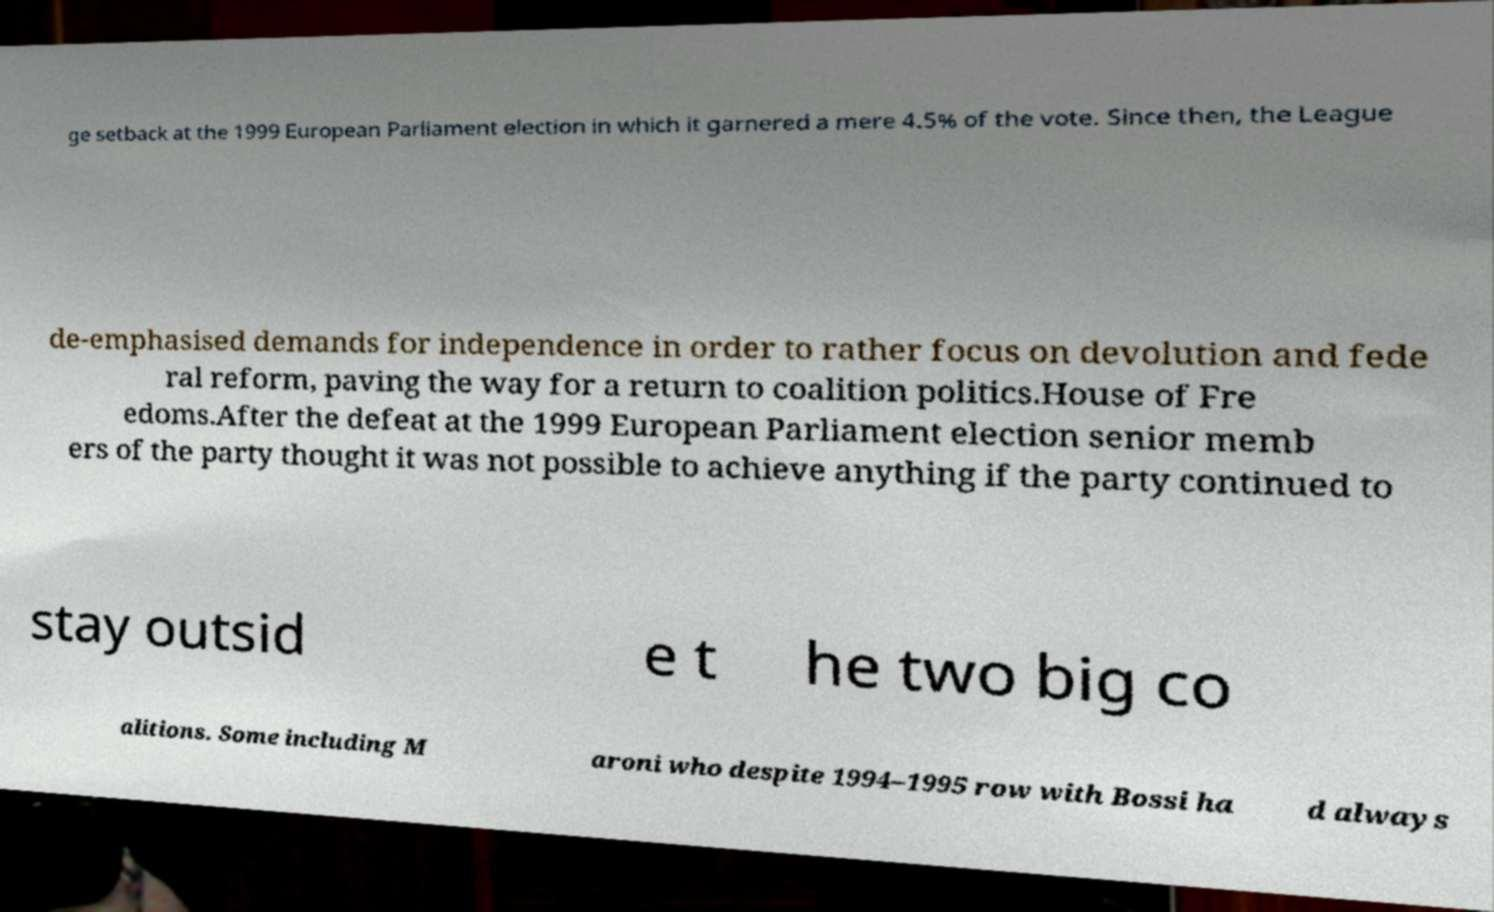Could you extract and type out the text from this image? ge setback at the 1999 European Parliament election in which it garnered a mere 4.5% of the vote. Since then, the League de-emphasised demands for independence in order to rather focus on devolution and fede ral reform, paving the way for a return to coalition politics.House of Fre edoms.After the defeat at the 1999 European Parliament election senior memb ers of the party thought it was not possible to achieve anything if the party continued to stay outsid e t he two big co alitions. Some including M aroni who despite 1994–1995 row with Bossi ha d always 